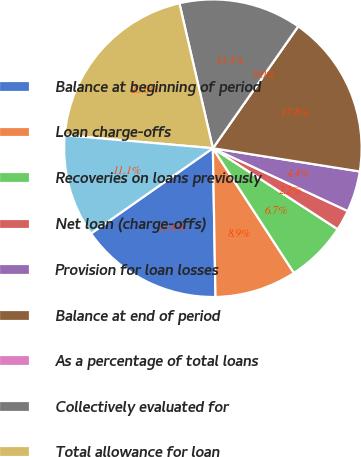Convert chart to OTSL. <chart><loc_0><loc_0><loc_500><loc_500><pie_chart><fcel>Balance at beginning of period<fcel>Loan charge-offs<fcel>Recoveries on loans previously<fcel>Net loan (charge-offs)<fcel>Provision for loan losses<fcel>Balance at end of period<fcel>As a percentage of total loans<fcel>Collectively evaluated for<fcel>Total allowance for loan<fcel>Individually evaluated for<nl><fcel>15.56%<fcel>8.89%<fcel>6.67%<fcel>2.22%<fcel>4.44%<fcel>17.78%<fcel>0.0%<fcel>13.33%<fcel>20.0%<fcel>11.11%<nl></chart> 